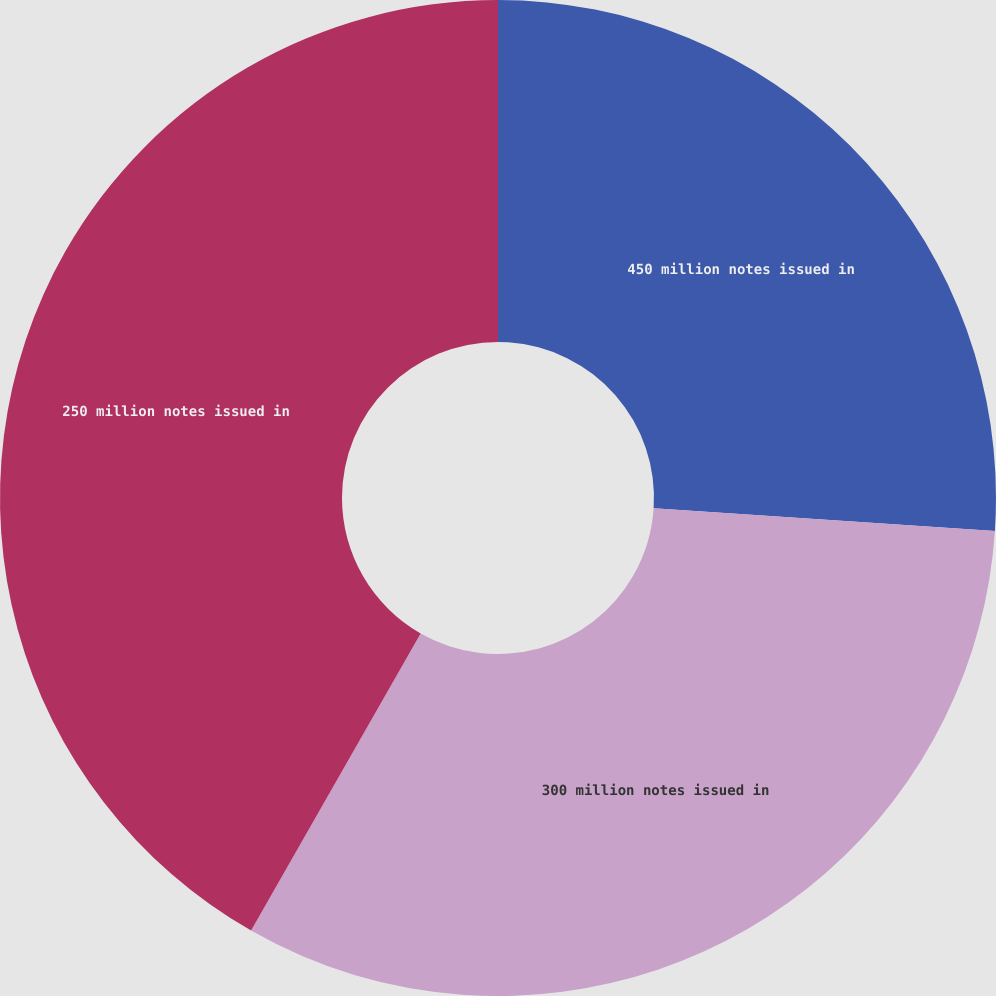<chart> <loc_0><loc_0><loc_500><loc_500><pie_chart><fcel>450 million notes issued in<fcel>300 million notes issued in<fcel>250 million notes issued in<nl><fcel>26.05%<fcel>32.2%<fcel>41.74%<nl></chart> 